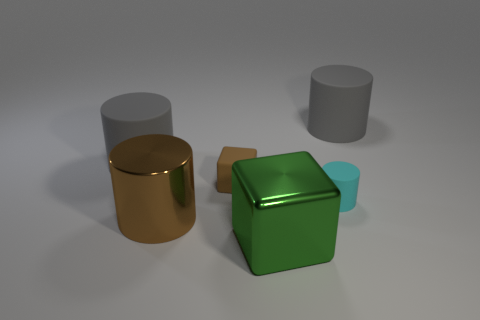What is the color of the small matte thing that is the same shape as the big green object?
Offer a very short reply. Brown. Do the rubber block and the brown shiny cylinder have the same size?
Make the answer very short. No. What number of things are either green shiny objects or gray objects that are to the left of the big brown object?
Make the answer very short. 2. There is a big cylinder that is in front of the large rubber thing that is on the left side of the big shiny cube; what is its color?
Ensure brevity in your answer.  Brown. Is the color of the block that is behind the metallic cylinder the same as the small rubber cylinder?
Your answer should be very brief. No. What material is the brown thing that is to the left of the small brown cube?
Offer a terse response. Metal. What is the size of the brown rubber cube?
Offer a terse response. Small. Does the gray cylinder that is on the left side of the brown metal thing have the same material as the brown cube?
Your response must be concise. Yes. How many gray cylinders are there?
Your answer should be very brief. 2. What number of things are either blue matte cubes or big objects?
Your answer should be compact. 4. 